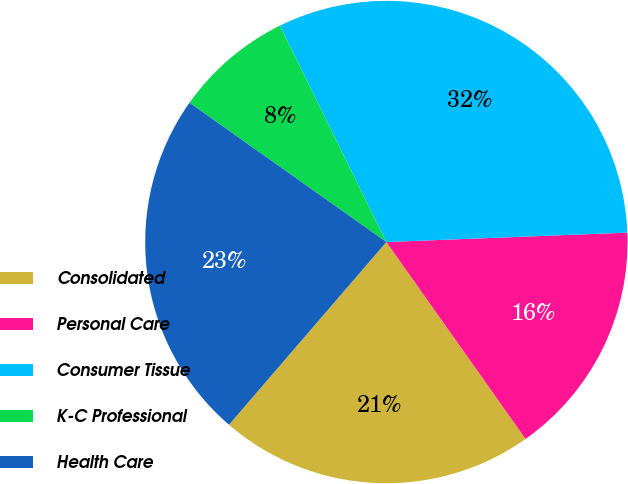Convert chart to OTSL. <chart><loc_0><loc_0><loc_500><loc_500><pie_chart><fcel>Consolidated<fcel>Personal Care<fcel>Consumer Tissue<fcel>K-C Professional<fcel>Health Care<nl><fcel>21.11%<fcel>15.83%<fcel>31.66%<fcel>7.92%<fcel>23.48%<nl></chart> 